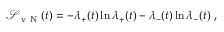Convert formula to latex. <formula><loc_0><loc_0><loc_500><loc_500>\begin{array} { r } { \mathcal { S } _ { v N } ( t ) = - \lambda _ { + } ( t ) \ln \lambda _ { + } ( t ) - \lambda _ { - } ( t ) \ln \lambda _ { - } ( t ) \ , } \end{array}</formula> 